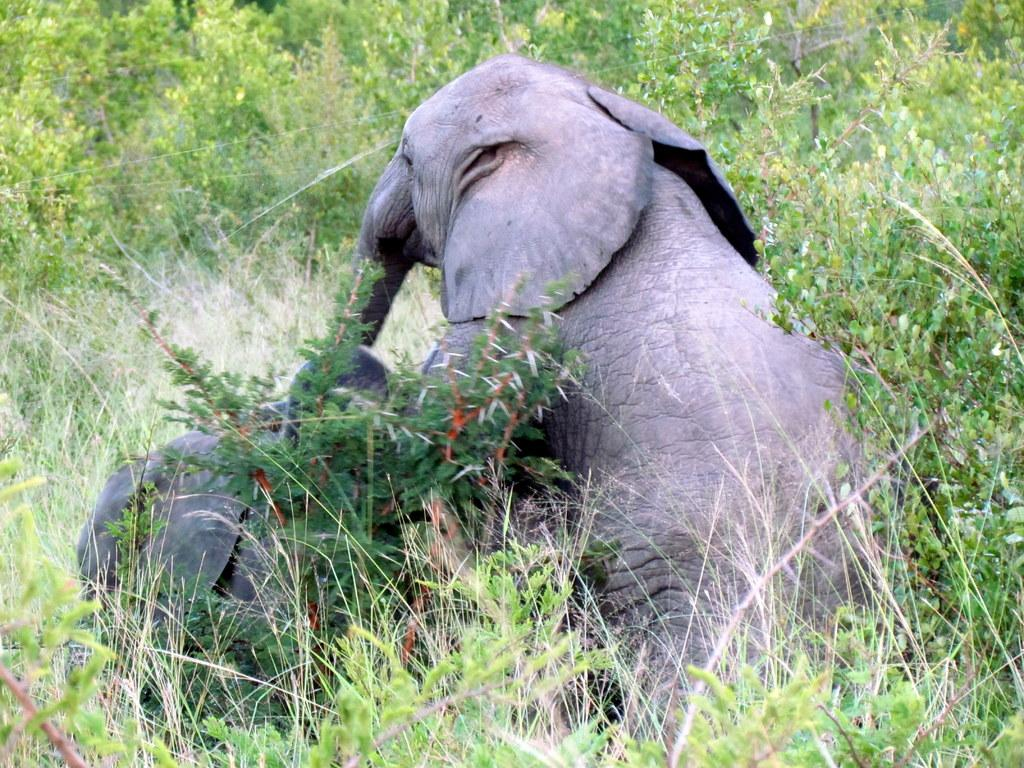How many elephants are present in the image? There are two elephants in the image. Can you describe the location of the elephants in the image? The elephants are in between the grass. What type of cake is being served at the elephant's birthday party in the image? There is no cake or birthday party present in the image; it features two elephants in between the grass. 